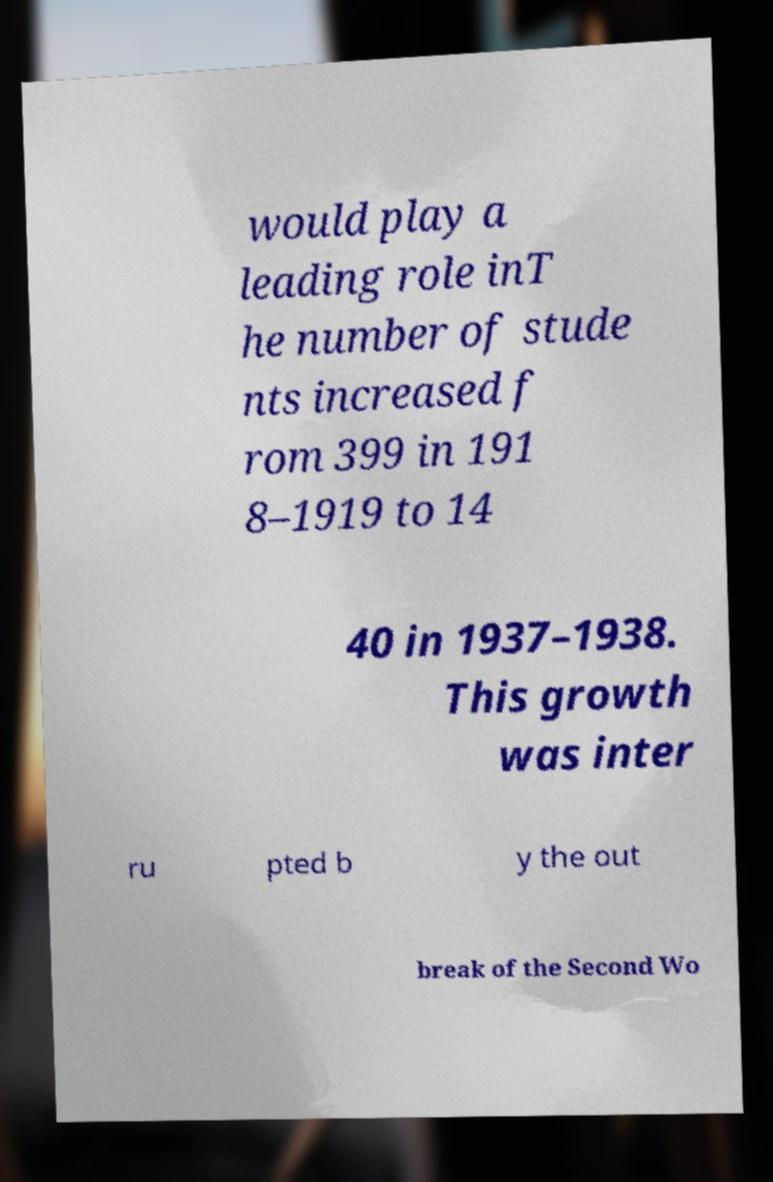Could you assist in decoding the text presented in this image and type it out clearly? would play a leading role inT he number of stude nts increased f rom 399 in 191 8–1919 to 14 40 in 1937–1938. This growth was inter ru pted b y the out break of the Second Wo 